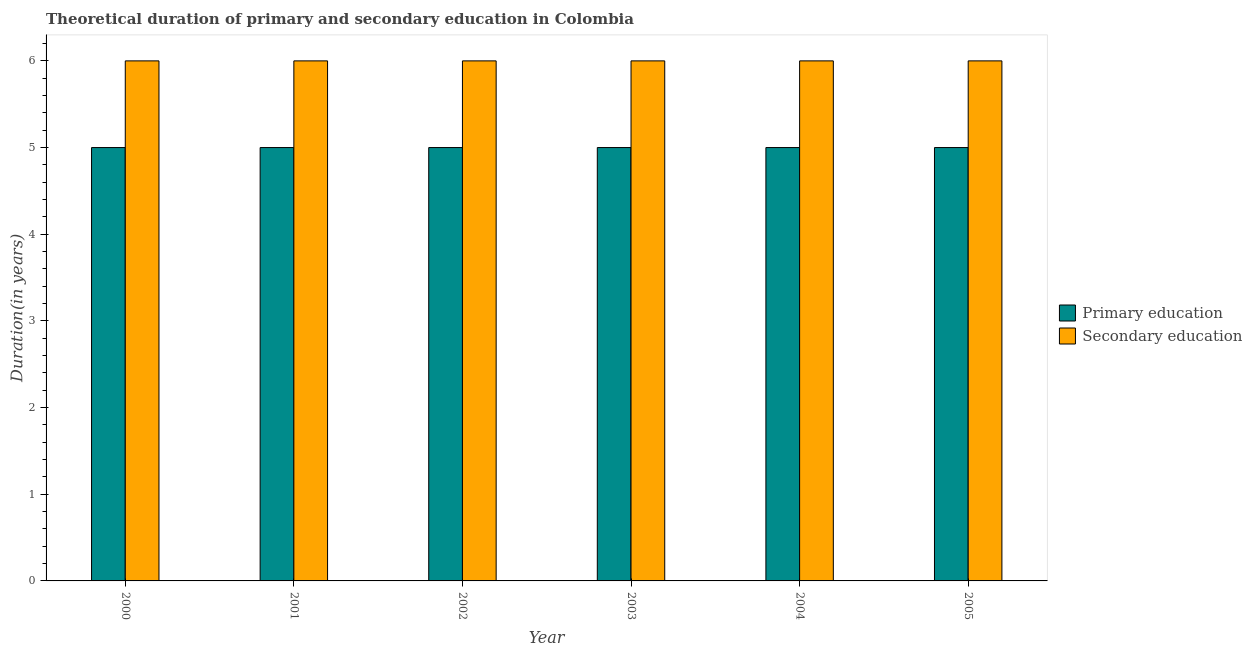How many different coloured bars are there?
Offer a terse response. 2. How many groups of bars are there?
Offer a very short reply. 6. Are the number of bars per tick equal to the number of legend labels?
Provide a short and direct response. Yes. Are the number of bars on each tick of the X-axis equal?
Keep it short and to the point. Yes. How many bars are there on the 2nd tick from the right?
Your response must be concise. 2. What is the duration of secondary education in 2004?
Provide a succinct answer. 6. Across all years, what is the maximum duration of secondary education?
Offer a very short reply. 6. Across all years, what is the minimum duration of primary education?
Give a very brief answer. 5. In which year was the duration of primary education maximum?
Offer a very short reply. 2000. In which year was the duration of primary education minimum?
Offer a very short reply. 2000. What is the total duration of secondary education in the graph?
Your answer should be compact. 36. What is the difference between the duration of secondary education in 2000 and that in 2001?
Your answer should be very brief. 0. What is the difference between the duration of secondary education in 2001 and the duration of primary education in 2002?
Offer a very short reply. 0. What does the 2nd bar from the left in 2000 represents?
Your answer should be compact. Secondary education. What does the 2nd bar from the right in 2000 represents?
Your answer should be compact. Primary education. Are all the bars in the graph horizontal?
Make the answer very short. No. What is the difference between two consecutive major ticks on the Y-axis?
Provide a succinct answer. 1. Are the values on the major ticks of Y-axis written in scientific E-notation?
Your response must be concise. No. Does the graph contain grids?
Provide a succinct answer. No. How many legend labels are there?
Ensure brevity in your answer.  2. How are the legend labels stacked?
Give a very brief answer. Vertical. What is the title of the graph?
Your answer should be very brief. Theoretical duration of primary and secondary education in Colombia. What is the label or title of the X-axis?
Give a very brief answer. Year. What is the label or title of the Y-axis?
Provide a short and direct response. Duration(in years). What is the Duration(in years) of Secondary education in 2000?
Your response must be concise. 6. What is the Duration(in years) in Primary education in 2001?
Keep it short and to the point. 5. What is the Duration(in years) in Secondary education in 2001?
Your answer should be very brief. 6. What is the Duration(in years) of Primary education in 2002?
Your answer should be compact. 5. What is the Duration(in years) in Primary education in 2003?
Offer a very short reply. 5. What is the Duration(in years) of Secondary education in 2003?
Provide a short and direct response. 6. What is the Duration(in years) in Primary education in 2004?
Offer a terse response. 5. What is the Duration(in years) of Secondary education in 2004?
Keep it short and to the point. 6. Across all years, what is the maximum Duration(in years) in Primary education?
Provide a short and direct response. 5. Across all years, what is the maximum Duration(in years) in Secondary education?
Give a very brief answer. 6. What is the total Duration(in years) in Primary education in the graph?
Ensure brevity in your answer.  30. What is the difference between the Duration(in years) of Primary education in 2000 and that in 2001?
Offer a terse response. 0. What is the difference between the Duration(in years) of Secondary education in 2000 and that in 2001?
Keep it short and to the point. 0. What is the difference between the Duration(in years) in Primary education in 2000 and that in 2003?
Provide a short and direct response. 0. What is the difference between the Duration(in years) in Primary education in 2000 and that in 2004?
Give a very brief answer. 0. What is the difference between the Duration(in years) in Secondary education in 2000 and that in 2004?
Offer a very short reply. 0. What is the difference between the Duration(in years) of Secondary education in 2001 and that in 2002?
Keep it short and to the point. 0. What is the difference between the Duration(in years) in Primary education in 2001 and that in 2003?
Provide a short and direct response. 0. What is the difference between the Duration(in years) in Secondary education in 2001 and that in 2004?
Ensure brevity in your answer.  0. What is the difference between the Duration(in years) in Primary education in 2001 and that in 2005?
Make the answer very short. 0. What is the difference between the Duration(in years) of Primary education in 2002 and that in 2005?
Your answer should be compact. 0. What is the difference between the Duration(in years) in Secondary education in 2002 and that in 2005?
Make the answer very short. 0. What is the difference between the Duration(in years) in Primary education in 2003 and that in 2004?
Keep it short and to the point. 0. What is the difference between the Duration(in years) of Primary education in 2000 and the Duration(in years) of Secondary education in 2003?
Provide a succinct answer. -1. What is the difference between the Duration(in years) of Primary education in 2002 and the Duration(in years) of Secondary education in 2003?
Make the answer very short. -1. What is the difference between the Duration(in years) in Primary education in 2002 and the Duration(in years) in Secondary education in 2004?
Make the answer very short. -1. What is the difference between the Duration(in years) in Primary education in 2003 and the Duration(in years) in Secondary education in 2005?
Provide a short and direct response. -1. What is the difference between the Duration(in years) in Primary education in 2004 and the Duration(in years) in Secondary education in 2005?
Provide a succinct answer. -1. What is the average Duration(in years) of Primary education per year?
Give a very brief answer. 5. In the year 2000, what is the difference between the Duration(in years) in Primary education and Duration(in years) in Secondary education?
Your answer should be compact. -1. In the year 2002, what is the difference between the Duration(in years) of Primary education and Duration(in years) of Secondary education?
Give a very brief answer. -1. In the year 2003, what is the difference between the Duration(in years) in Primary education and Duration(in years) in Secondary education?
Keep it short and to the point. -1. What is the ratio of the Duration(in years) in Secondary education in 2000 to that in 2001?
Ensure brevity in your answer.  1. What is the ratio of the Duration(in years) of Primary education in 2000 to that in 2002?
Make the answer very short. 1. What is the ratio of the Duration(in years) of Secondary education in 2000 to that in 2002?
Give a very brief answer. 1. What is the ratio of the Duration(in years) in Primary education in 2000 to that in 2003?
Give a very brief answer. 1. What is the ratio of the Duration(in years) of Secondary education in 2000 to that in 2004?
Your answer should be compact. 1. What is the ratio of the Duration(in years) in Primary education in 2000 to that in 2005?
Give a very brief answer. 1. What is the ratio of the Duration(in years) in Secondary education in 2000 to that in 2005?
Your answer should be very brief. 1. What is the ratio of the Duration(in years) of Secondary education in 2001 to that in 2002?
Offer a terse response. 1. What is the ratio of the Duration(in years) of Primary education in 2001 to that in 2003?
Give a very brief answer. 1. What is the ratio of the Duration(in years) of Primary education in 2001 to that in 2004?
Offer a very short reply. 1. What is the ratio of the Duration(in years) in Primary education in 2002 to that in 2003?
Keep it short and to the point. 1. What is the ratio of the Duration(in years) of Primary education in 2002 to that in 2004?
Keep it short and to the point. 1. What is the ratio of the Duration(in years) of Primary education in 2002 to that in 2005?
Your answer should be very brief. 1. What is the ratio of the Duration(in years) in Secondary education in 2003 to that in 2004?
Your response must be concise. 1. What is the ratio of the Duration(in years) in Secondary education in 2004 to that in 2005?
Offer a very short reply. 1. What is the difference between the highest and the second highest Duration(in years) in Secondary education?
Give a very brief answer. 0. What is the difference between the highest and the lowest Duration(in years) of Primary education?
Offer a terse response. 0. What is the difference between the highest and the lowest Duration(in years) in Secondary education?
Offer a very short reply. 0. 